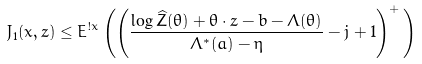Convert formula to latex. <formula><loc_0><loc_0><loc_500><loc_500>J _ { 1 } ( x , z ) \leq E ^ { ! x } \left ( \left ( \frac { \log \widehat { Z } ( \theta ) + \theta \cdot z - b - \Lambda ( \theta ) } { \Lambda ^ { * } ( a ) - \eta } - j + 1 \right ) ^ { + } \, \right )</formula> 